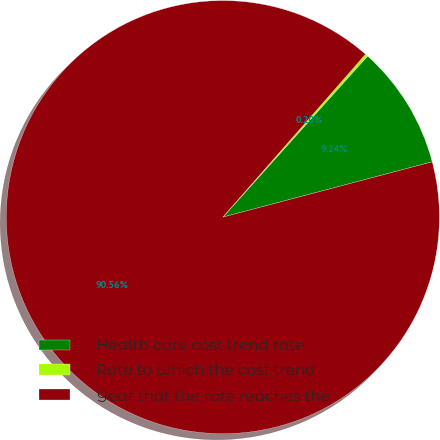Convert chart. <chart><loc_0><loc_0><loc_500><loc_500><pie_chart><fcel>Health care cost trend rate<fcel>Rate to which the cost trend<fcel>Year that the rate reaches the<nl><fcel>9.24%<fcel>0.2%<fcel>90.56%<nl></chart> 